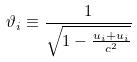<formula> <loc_0><loc_0><loc_500><loc_500>\vartheta _ { i } \equiv \frac { 1 } { \sqrt { 1 - \frac { u _ { i } + u _ { i } } { c ^ { 2 } } } }</formula> 